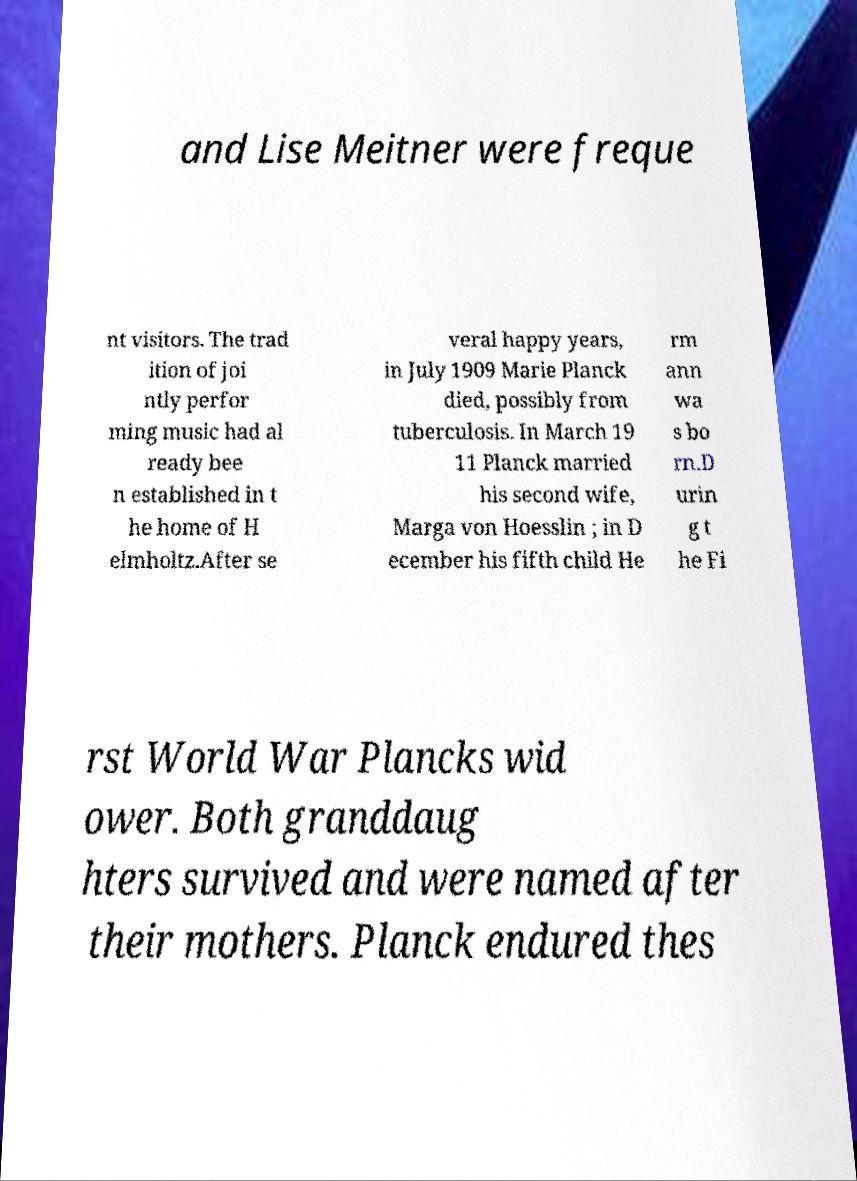Please read and relay the text visible in this image. What does it say? and Lise Meitner were freque nt visitors. The trad ition of joi ntly perfor ming music had al ready bee n established in t he home of H elmholtz.After se veral happy years, in July 1909 Marie Planck died, possibly from tuberculosis. In March 19 11 Planck married his second wife, Marga von Hoesslin ; in D ecember his fifth child He rm ann wa s bo rn.D urin g t he Fi rst World War Plancks wid ower. Both granddaug hters survived and were named after their mothers. Planck endured thes 